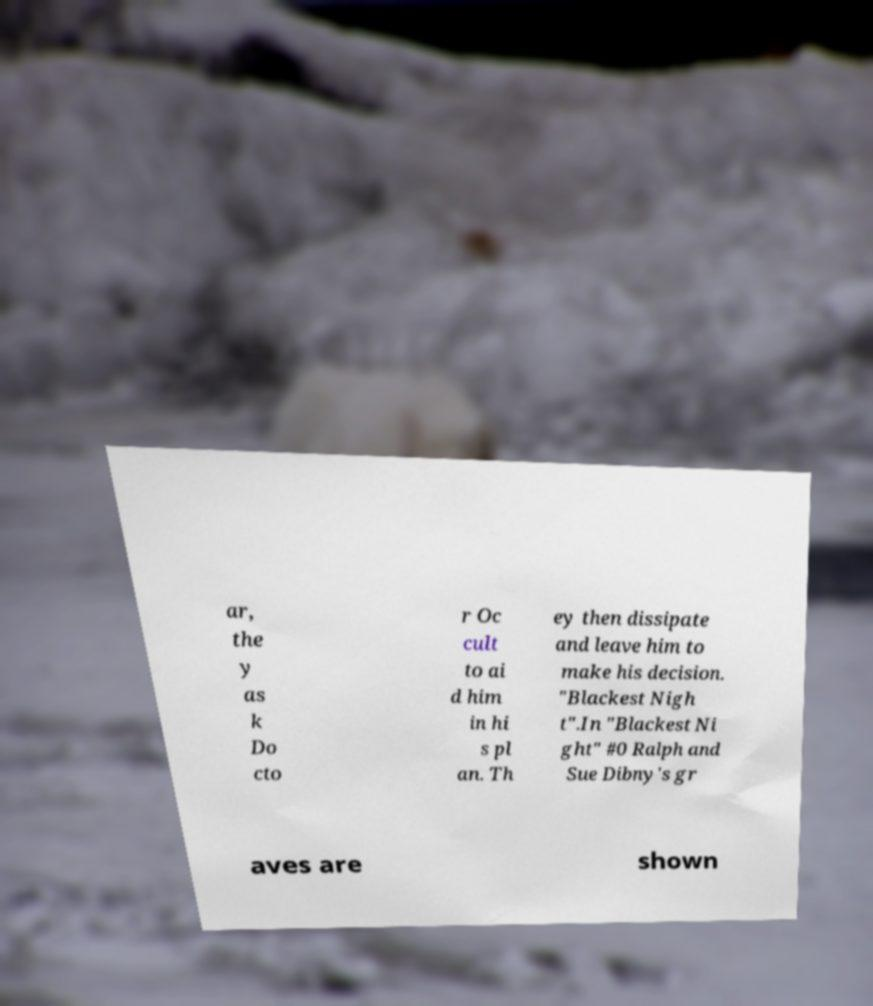Please read and relay the text visible in this image. What does it say? ar, the y as k Do cto r Oc cult to ai d him in hi s pl an. Th ey then dissipate and leave him to make his decision. "Blackest Nigh t".In "Blackest Ni ght" #0 Ralph and Sue Dibny's gr aves are shown 